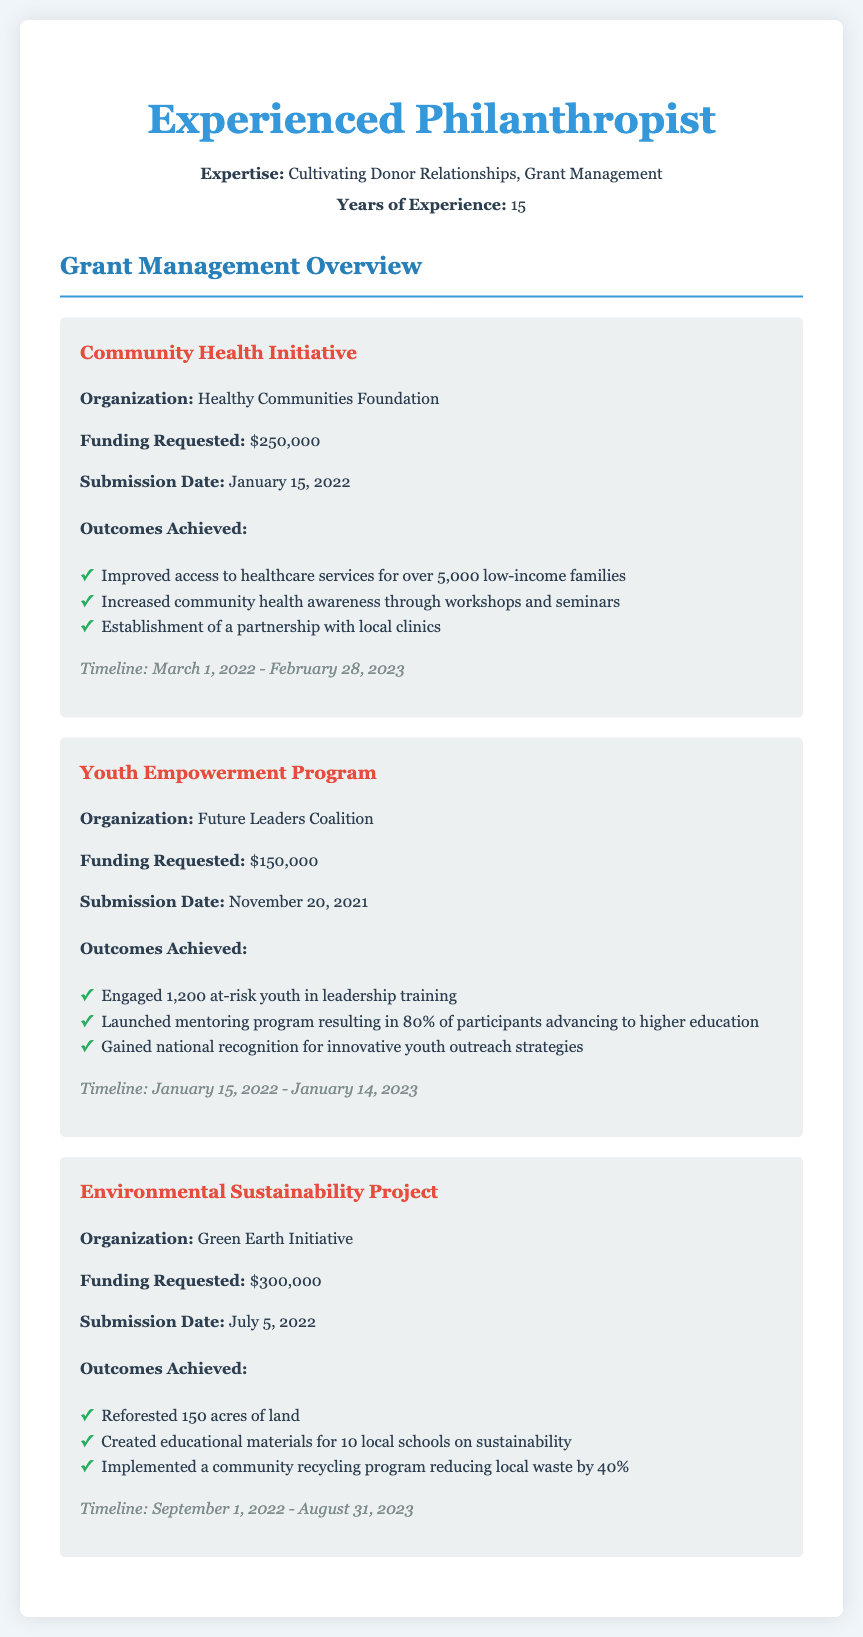what is the funding requested for the Community Health Initiative? The document specifies that the funding requested for the Community Health Initiative is $250,000.
Answer: $250,000 who is the organization for the Youth Empowerment Program? According to the document, the organization for the Youth Empowerment Program is Future Leaders Coalition.
Answer: Future Leaders Coalition how many acres were reforested in the Environmental Sustainability Project? The document states that 150 acres of land were reforested in the Environmental Sustainability Project.
Answer: 150 acres what was the submission date of the Community Health Initiative proposal? The Community Health Initiative proposal was submitted on January 15, 2022, as per the document.
Answer: January 15, 2022 what percentage of Youth Empowerment Program participants advanced to higher education? The document indicates that 80% of participants in the Youth Empowerment Program advanced to higher education.
Answer: 80% which project achieved national recognition for its outreach strategies? The document shows that the Youth Empowerment Program gained national recognition for innovative youth outreach strategies.
Answer: Youth Empowerment Program what is the timeline for the Environmental Sustainability Project? The timeline for the Environmental Sustainability Project is noted in the document as September 1, 2022 - August 31, 2023.
Answer: September 1, 2022 - August 31, 2023 how many low-income families improved access to healthcare services through the Community Health Initiative? The document highlights that over 5,000 low-income families improved access to healthcare services through the Community Health Initiative.
Answer: over 5,000 what is the total amount of funding requested across all three projects? The total funding requested is $250,000 + $150,000 + $300,000 per the document, totaling $700,000.
Answer: $700,000 